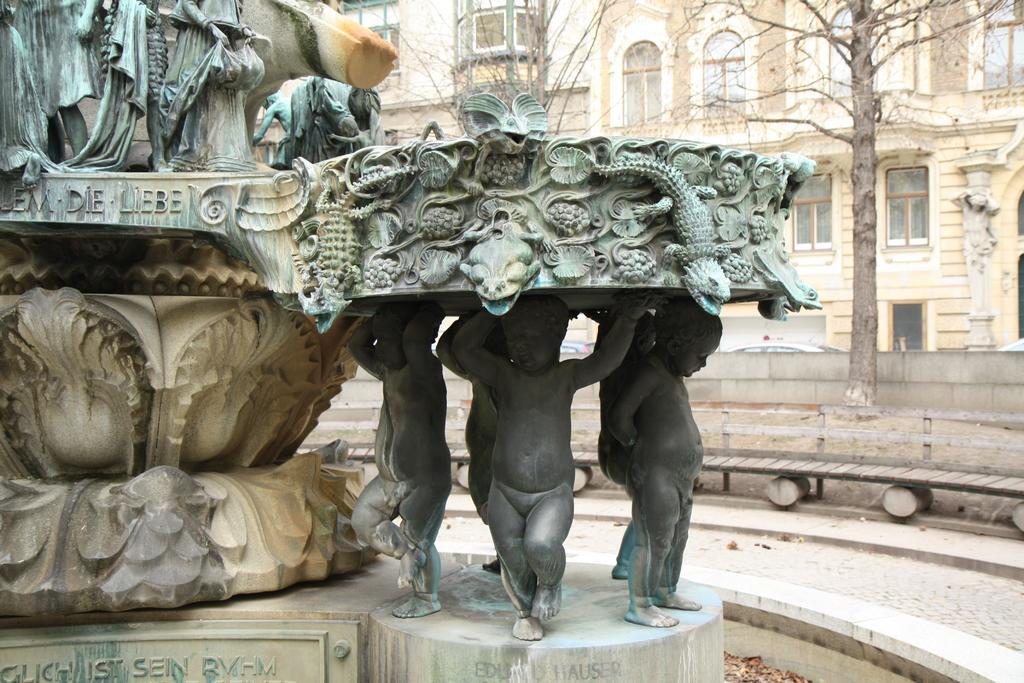In one or two sentences, can you explain what this image depicts? In the foreground of the picture there is a sculpture and there are dry leaves. In the center of the picture there are trees, wall and wooden object. In the background there are cars and buildings. 